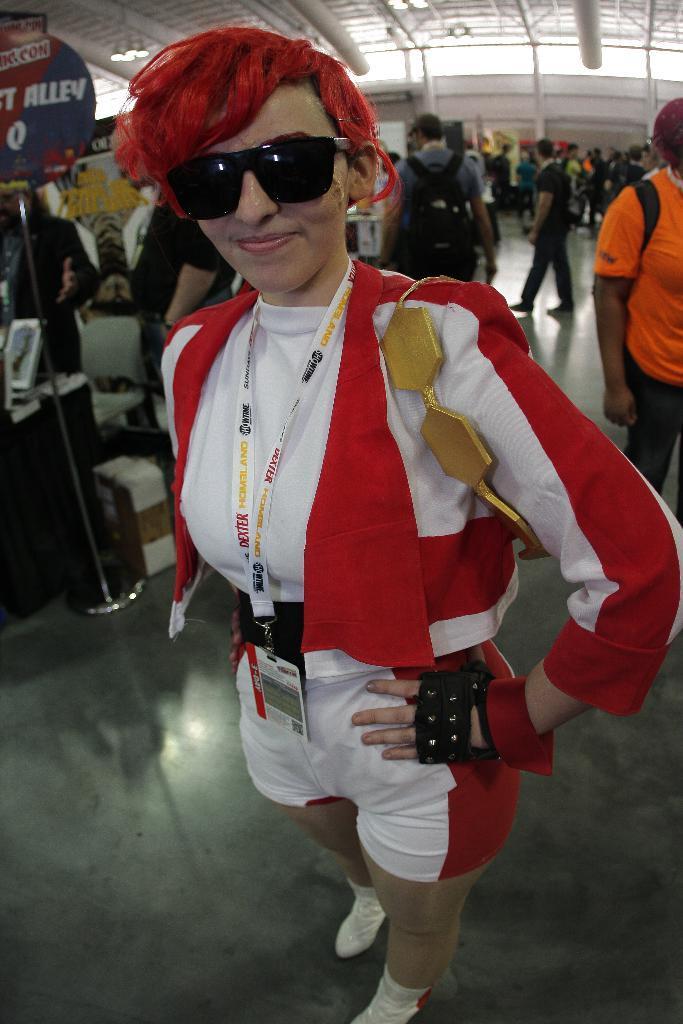Describe this image in one or two sentences. This picture describes about group of people, in the middle of the image we can see a person, the person wore spectacles and a tag, in the background we can see a sign board, box, few metal rods and lights. 